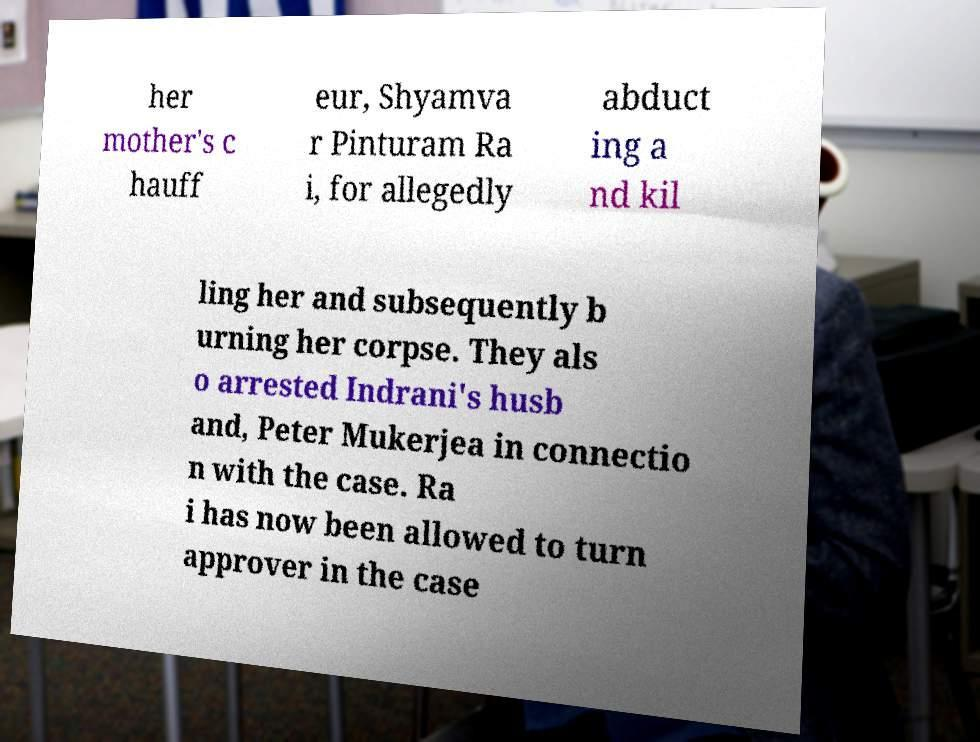For documentation purposes, I need the text within this image transcribed. Could you provide that? her mother's c hauff eur, Shyamva r Pinturam Ra i, for allegedly abduct ing a nd kil ling her and subsequently b urning her corpse. They als o arrested Indrani's husb and, Peter Mukerjea in connectio n with the case. Ra i has now been allowed to turn approver in the case 